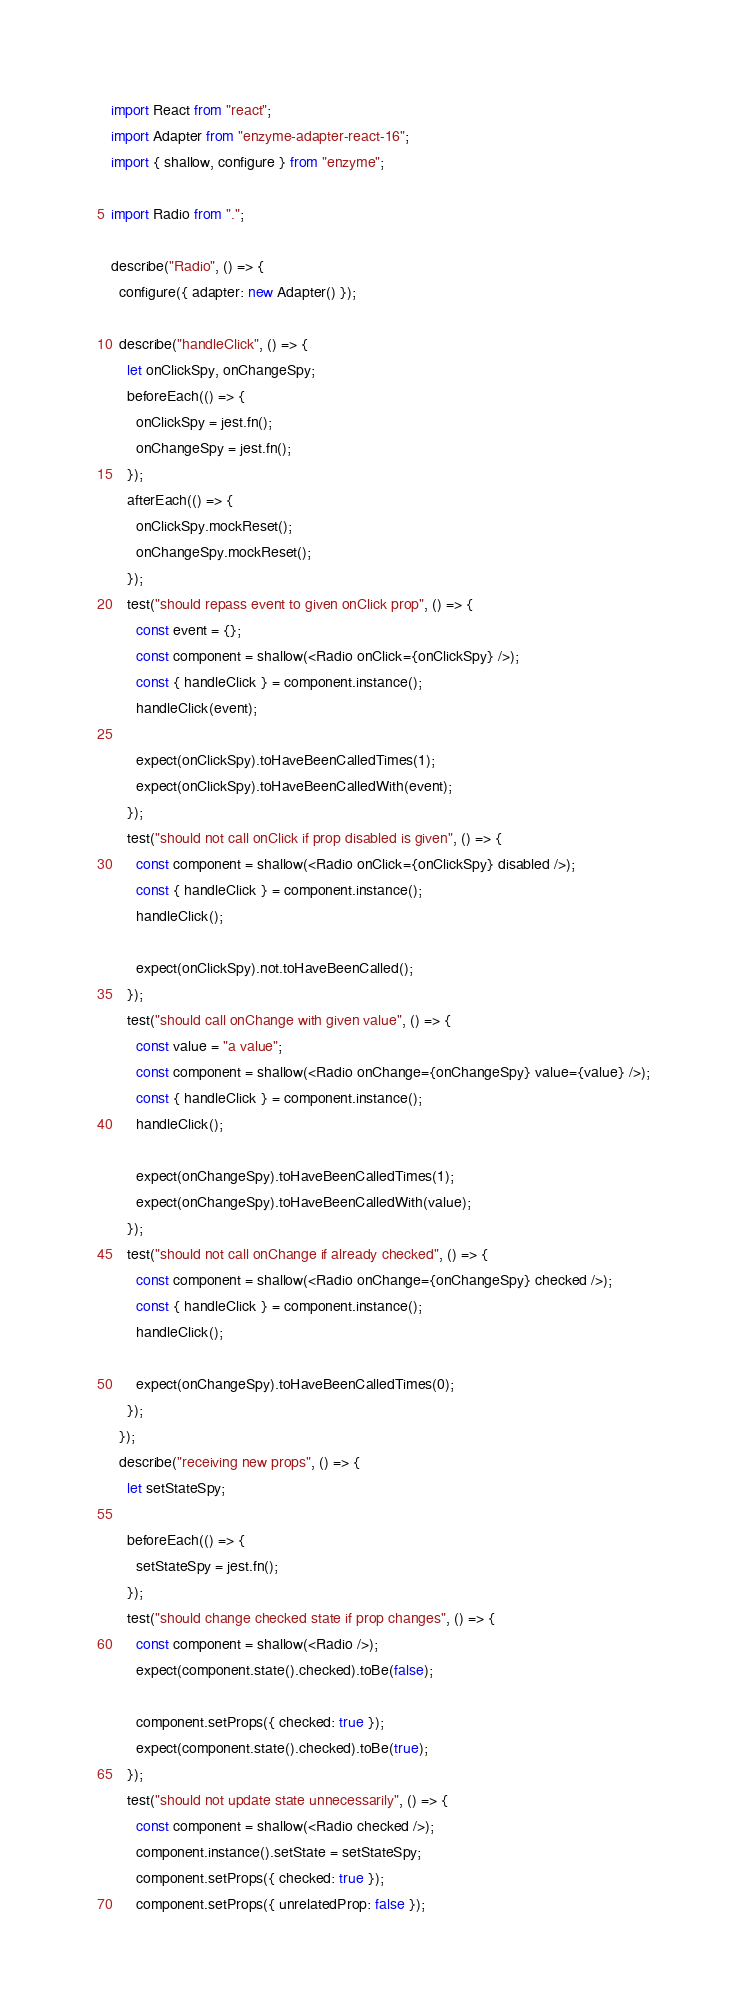<code> <loc_0><loc_0><loc_500><loc_500><_JavaScript_>import React from "react";
import Adapter from "enzyme-adapter-react-16";
import { shallow, configure } from "enzyme";

import Radio from ".";

describe("Radio", () => {
  configure({ adapter: new Adapter() });

  describe("handleClick", () => {
    let onClickSpy, onChangeSpy;
    beforeEach(() => {
      onClickSpy = jest.fn();
      onChangeSpy = jest.fn();
    });
    afterEach(() => {
      onClickSpy.mockReset();
      onChangeSpy.mockReset();
    });
    test("should repass event to given onClick prop", () => {
      const event = {};
      const component = shallow(<Radio onClick={onClickSpy} />);
      const { handleClick } = component.instance();
      handleClick(event);

      expect(onClickSpy).toHaveBeenCalledTimes(1);
      expect(onClickSpy).toHaveBeenCalledWith(event);
    });
    test("should not call onClick if prop disabled is given", () => {
      const component = shallow(<Radio onClick={onClickSpy} disabled />);
      const { handleClick } = component.instance();
      handleClick();

      expect(onClickSpy).not.toHaveBeenCalled();
    });
    test("should call onChange with given value", () => {
      const value = "a value";
      const component = shallow(<Radio onChange={onChangeSpy} value={value} />);
      const { handleClick } = component.instance();
      handleClick();

      expect(onChangeSpy).toHaveBeenCalledTimes(1);
      expect(onChangeSpy).toHaveBeenCalledWith(value);
    });
    test("should not call onChange if already checked", () => {
      const component = shallow(<Radio onChange={onChangeSpy} checked />);
      const { handleClick } = component.instance();
      handleClick();

      expect(onChangeSpy).toHaveBeenCalledTimes(0);
    });
  });
  describe("receiving new props", () => {
    let setStateSpy;

    beforeEach(() => {
      setStateSpy = jest.fn();
    });
    test("should change checked state if prop changes", () => {
      const component = shallow(<Radio />);
      expect(component.state().checked).toBe(false);

      component.setProps({ checked: true });
      expect(component.state().checked).toBe(true);
    });
    test("should not update state unnecessarily", () => {
      const component = shallow(<Radio checked />);
      component.instance().setState = setStateSpy;
      component.setProps({ checked: true });
      component.setProps({ unrelatedProp: false });</code> 